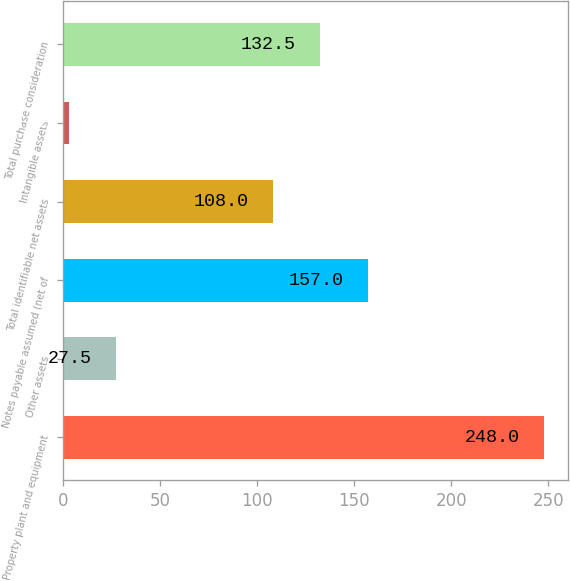Convert chart to OTSL. <chart><loc_0><loc_0><loc_500><loc_500><bar_chart><fcel>Property plant and equipment<fcel>Other assets<fcel>Notes payable assumed (net of<fcel>Total identifiable net assets<fcel>Intangible assets<fcel>Total purchase consideration<nl><fcel>248<fcel>27.5<fcel>157<fcel>108<fcel>3<fcel>132.5<nl></chart> 